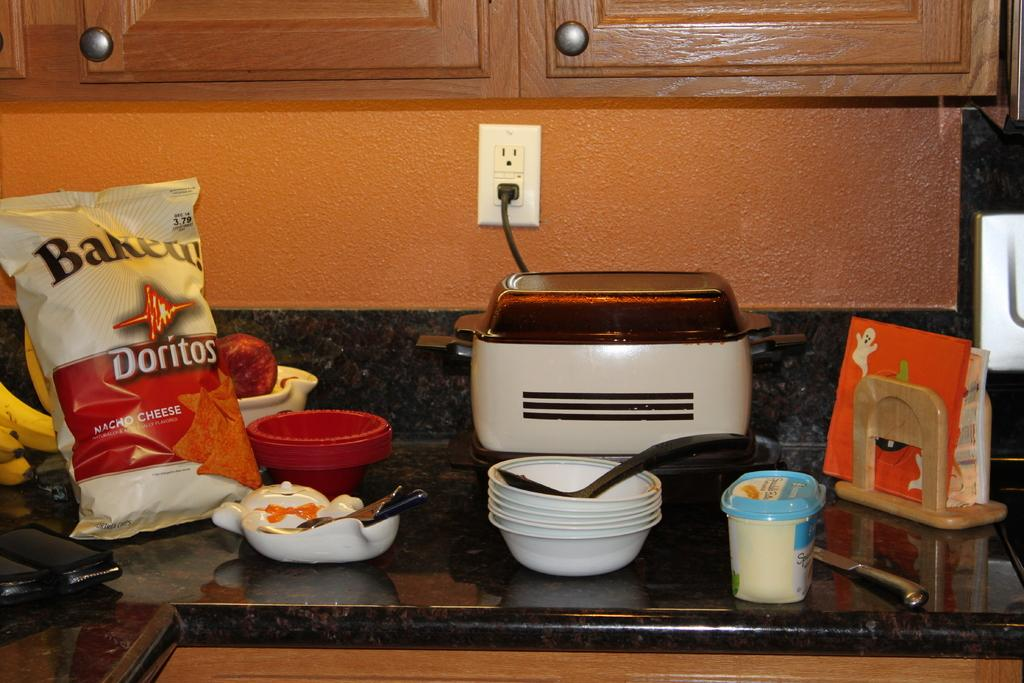<image>
Present a compact description of the photo's key features. A kitchen counter with various items including a bag of baked doritos 